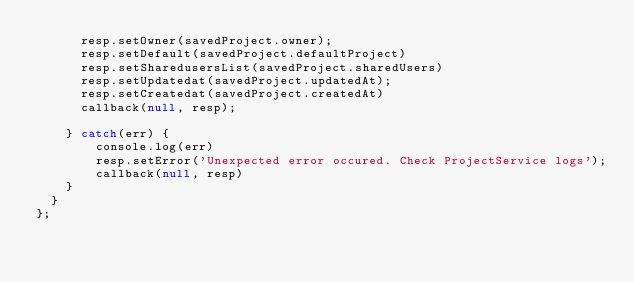<code> <loc_0><loc_0><loc_500><loc_500><_JavaScript_>      resp.setOwner(savedProject.owner);
      resp.setDefault(savedProject.defaultProject)
      resp.setSharedusersList(savedProject.sharedUsers)
      resp.setUpdatedat(savedProject.updatedAt);
      resp.setCreatedat(savedProject.createdAt)
      callback(null, resp);

    } catch(err) {
        console.log(err)
        resp.setError('Unexpected error occured. Check ProjectService logs');
        callback(null, resp)
    }
  }
};</code> 